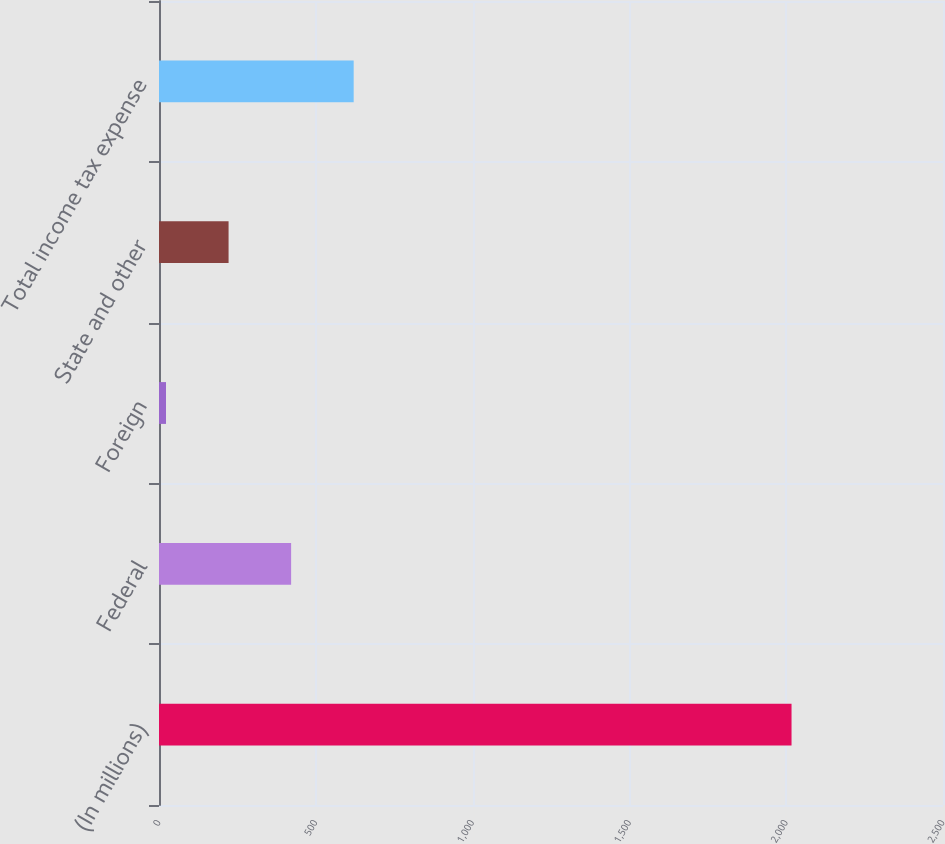<chart> <loc_0><loc_0><loc_500><loc_500><bar_chart><fcel>(In millions)<fcel>Federal<fcel>Foreign<fcel>State and other<fcel>Total income tax expense<nl><fcel>2017<fcel>421.32<fcel>22.4<fcel>221.86<fcel>620.78<nl></chart> 